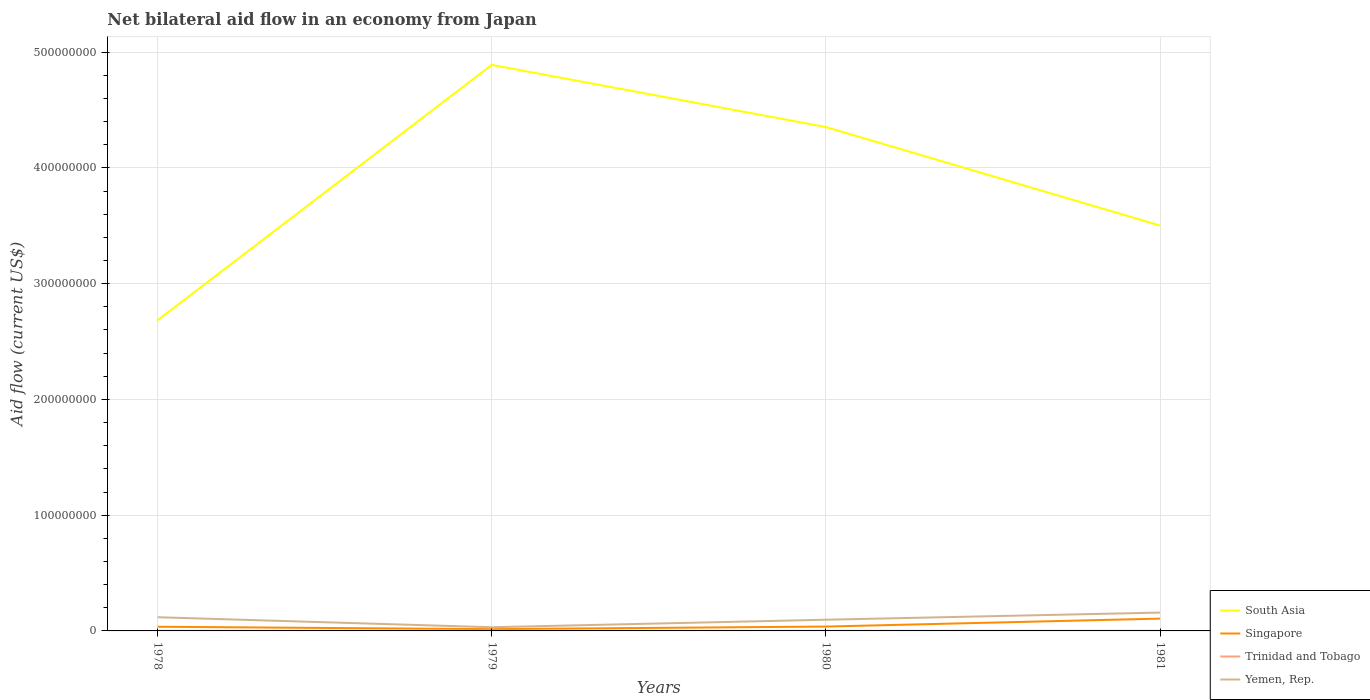Does the line corresponding to Yemen, Rep. intersect with the line corresponding to Singapore?
Offer a very short reply. No. Across all years, what is the maximum net bilateral aid flow in Trinidad and Tobago?
Provide a succinct answer. 9.00e+04. In which year was the net bilateral aid flow in Trinidad and Tobago maximum?
Make the answer very short. 1980. What is the difference between the highest and the second highest net bilateral aid flow in South Asia?
Provide a succinct answer. 2.21e+08. What is the difference between the highest and the lowest net bilateral aid flow in Singapore?
Your answer should be compact. 1. What is the difference between two consecutive major ticks on the Y-axis?
Provide a succinct answer. 1.00e+08. Does the graph contain any zero values?
Provide a short and direct response. No. Does the graph contain grids?
Your response must be concise. Yes. Where does the legend appear in the graph?
Ensure brevity in your answer.  Bottom right. How many legend labels are there?
Ensure brevity in your answer.  4. What is the title of the graph?
Your answer should be compact. Net bilateral aid flow in an economy from Japan. What is the label or title of the Y-axis?
Give a very brief answer. Aid flow (current US$). What is the Aid flow (current US$) of South Asia in 1978?
Provide a succinct answer. 2.68e+08. What is the Aid flow (current US$) of Singapore in 1978?
Your answer should be very brief. 3.60e+06. What is the Aid flow (current US$) of Trinidad and Tobago in 1978?
Offer a very short reply. 1.10e+05. What is the Aid flow (current US$) in Yemen, Rep. in 1978?
Your answer should be very brief. 1.18e+07. What is the Aid flow (current US$) in South Asia in 1979?
Keep it short and to the point. 4.89e+08. What is the Aid flow (current US$) of Singapore in 1979?
Your answer should be compact. 1.52e+06. What is the Aid flow (current US$) of Trinidad and Tobago in 1979?
Keep it short and to the point. 1.90e+05. What is the Aid flow (current US$) of Yemen, Rep. in 1979?
Ensure brevity in your answer.  3.19e+06. What is the Aid flow (current US$) in South Asia in 1980?
Provide a succinct answer. 4.35e+08. What is the Aid flow (current US$) in Singapore in 1980?
Provide a short and direct response. 3.77e+06. What is the Aid flow (current US$) in Trinidad and Tobago in 1980?
Offer a terse response. 9.00e+04. What is the Aid flow (current US$) in Yemen, Rep. in 1980?
Provide a succinct answer. 9.68e+06. What is the Aid flow (current US$) in South Asia in 1981?
Keep it short and to the point. 3.50e+08. What is the Aid flow (current US$) of Singapore in 1981?
Offer a terse response. 1.06e+07. What is the Aid flow (current US$) in Yemen, Rep. in 1981?
Provide a succinct answer. 1.58e+07. Across all years, what is the maximum Aid flow (current US$) in South Asia?
Keep it short and to the point. 4.89e+08. Across all years, what is the maximum Aid flow (current US$) in Singapore?
Offer a terse response. 1.06e+07. Across all years, what is the maximum Aid flow (current US$) of Trinidad and Tobago?
Your answer should be compact. 1.90e+05. Across all years, what is the maximum Aid flow (current US$) in Yemen, Rep.?
Ensure brevity in your answer.  1.58e+07. Across all years, what is the minimum Aid flow (current US$) in South Asia?
Ensure brevity in your answer.  2.68e+08. Across all years, what is the minimum Aid flow (current US$) of Singapore?
Your answer should be very brief. 1.52e+06. Across all years, what is the minimum Aid flow (current US$) in Yemen, Rep.?
Your answer should be compact. 3.19e+06. What is the total Aid flow (current US$) in South Asia in the graph?
Provide a succinct answer. 1.54e+09. What is the total Aid flow (current US$) in Singapore in the graph?
Provide a succinct answer. 1.95e+07. What is the total Aid flow (current US$) in Trinidad and Tobago in the graph?
Give a very brief answer. 5.30e+05. What is the total Aid flow (current US$) in Yemen, Rep. in the graph?
Your answer should be compact. 4.05e+07. What is the difference between the Aid flow (current US$) of South Asia in 1978 and that in 1979?
Ensure brevity in your answer.  -2.21e+08. What is the difference between the Aid flow (current US$) in Singapore in 1978 and that in 1979?
Keep it short and to the point. 2.08e+06. What is the difference between the Aid flow (current US$) in Trinidad and Tobago in 1978 and that in 1979?
Offer a very short reply. -8.00e+04. What is the difference between the Aid flow (current US$) of Yemen, Rep. in 1978 and that in 1979?
Offer a very short reply. 8.63e+06. What is the difference between the Aid flow (current US$) of South Asia in 1978 and that in 1980?
Your response must be concise. -1.67e+08. What is the difference between the Aid flow (current US$) of Trinidad and Tobago in 1978 and that in 1980?
Your answer should be very brief. 2.00e+04. What is the difference between the Aid flow (current US$) of Yemen, Rep. in 1978 and that in 1980?
Your answer should be very brief. 2.14e+06. What is the difference between the Aid flow (current US$) of South Asia in 1978 and that in 1981?
Ensure brevity in your answer.  -8.18e+07. What is the difference between the Aid flow (current US$) of Singapore in 1978 and that in 1981?
Make the answer very short. -7.04e+06. What is the difference between the Aid flow (current US$) of Yemen, Rep. in 1978 and that in 1981?
Your answer should be very brief. -4.03e+06. What is the difference between the Aid flow (current US$) of South Asia in 1979 and that in 1980?
Offer a very short reply. 5.37e+07. What is the difference between the Aid flow (current US$) in Singapore in 1979 and that in 1980?
Keep it short and to the point. -2.25e+06. What is the difference between the Aid flow (current US$) of Yemen, Rep. in 1979 and that in 1980?
Your response must be concise. -6.49e+06. What is the difference between the Aid flow (current US$) in South Asia in 1979 and that in 1981?
Ensure brevity in your answer.  1.39e+08. What is the difference between the Aid flow (current US$) of Singapore in 1979 and that in 1981?
Keep it short and to the point. -9.12e+06. What is the difference between the Aid flow (current US$) in Trinidad and Tobago in 1979 and that in 1981?
Offer a very short reply. 5.00e+04. What is the difference between the Aid flow (current US$) in Yemen, Rep. in 1979 and that in 1981?
Your answer should be compact. -1.27e+07. What is the difference between the Aid flow (current US$) in South Asia in 1980 and that in 1981?
Offer a terse response. 8.51e+07. What is the difference between the Aid flow (current US$) of Singapore in 1980 and that in 1981?
Your answer should be very brief. -6.87e+06. What is the difference between the Aid flow (current US$) in Trinidad and Tobago in 1980 and that in 1981?
Give a very brief answer. -5.00e+04. What is the difference between the Aid flow (current US$) in Yemen, Rep. in 1980 and that in 1981?
Keep it short and to the point. -6.17e+06. What is the difference between the Aid flow (current US$) of South Asia in 1978 and the Aid flow (current US$) of Singapore in 1979?
Provide a succinct answer. 2.67e+08. What is the difference between the Aid flow (current US$) of South Asia in 1978 and the Aid flow (current US$) of Trinidad and Tobago in 1979?
Offer a very short reply. 2.68e+08. What is the difference between the Aid flow (current US$) of South Asia in 1978 and the Aid flow (current US$) of Yemen, Rep. in 1979?
Provide a succinct answer. 2.65e+08. What is the difference between the Aid flow (current US$) in Singapore in 1978 and the Aid flow (current US$) in Trinidad and Tobago in 1979?
Provide a succinct answer. 3.41e+06. What is the difference between the Aid flow (current US$) in Singapore in 1978 and the Aid flow (current US$) in Yemen, Rep. in 1979?
Provide a succinct answer. 4.10e+05. What is the difference between the Aid flow (current US$) of Trinidad and Tobago in 1978 and the Aid flow (current US$) of Yemen, Rep. in 1979?
Your response must be concise. -3.08e+06. What is the difference between the Aid flow (current US$) of South Asia in 1978 and the Aid flow (current US$) of Singapore in 1980?
Your answer should be very brief. 2.65e+08. What is the difference between the Aid flow (current US$) in South Asia in 1978 and the Aid flow (current US$) in Trinidad and Tobago in 1980?
Ensure brevity in your answer.  2.68e+08. What is the difference between the Aid flow (current US$) of South Asia in 1978 and the Aid flow (current US$) of Yemen, Rep. in 1980?
Your answer should be compact. 2.59e+08. What is the difference between the Aid flow (current US$) of Singapore in 1978 and the Aid flow (current US$) of Trinidad and Tobago in 1980?
Your response must be concise. 3.51e+06. What is the difference between the Aid flow (current US$) in Singapore in 1978 and the Aid flow (current US$) in Yemen, Rep. in 1980?
Make the answer very short. -6.08e+06. What is the difference between the Aid flow (current US$) in Trinidad and Tobago in 1978 and the Aid flow (current US$) in Yemen, Rep. in 1980?
Give a very brief answer. -9.57e+06. What is the difference between the Aid flow (current US$) of South Asia in 1978 and the Aid flow (current US$) of Singapore in 1981?
Your answer should be very brief. 2.58e+08. What is the difference between the Aid flow (current US$) in South Asia in 1978 and the Aid flow (current US$) in Trinidad and Tobago in 1981?
Give a very brief answer. 2.68e+08. What is the difference between the Aid flow (current US$) of South Asia in 1978 and the Aid flow (current US$) of Yemen, Rep. in 1981?
Provide a short and direct response. 2.53e+08. What is the difference between the Aid flow (current US$) in Singapore in 1978 and the Aid flow (current US$) in Trinidad and Tobago in 1981?
Offer a terse response. 3.46e+06. What is the difference between the Aid flow (current US$) of Singapore in 1978 and the Aid flow (current US$) of Yemen, Rep. in 1981?
Offer a very short reply. -1.22e+07. What is the difference between the Aid flow (current US$) of Trinidad and Tobago in 1978 and the Aid flow (current US$) of Yemen, Rep. in 1981?
Your response must be concise. -1.57e+07. What is the difference between the Aid flow (current US$) of South Asia in 1979 and the Aid flow (current US$) of Singapore in 1980?
Give a very brief answer. 4.85e+08. What is the difference between the Aid flow (current US$) in South Asia in 1979 and the Aid flow (current US$) in Trinidad and Tobago in 1980?
Make the answer very short. 4.89e+08. What is the difference between the Aid flow (current US$) of South Asia in 1979 and the Aid flow (current US$) of Yemen, Rep. in 1980?
Give a very brief answer. 4.79e+08. What is the difference between the Aid flow (current US$) in Singapore in 1979 and the Aid flow (current US$) in Trinidad and Tobago in 1980?
Your answer should be compact. 1.43e+06. What is the difference between the Aid flow (current US$) in Singapore in 1979 and the Aid flow (current US$) in Yemen, Rep. in 1980?
Keep it short and to the point. -8.16e+06. What is the difference between the Aid flow (current US$) in Trinidad and Tobago in 1979 and the Aid flow (current US$) in Yemen, Rep. in 1980?
Your response must be concise. -9.49e+06. What is the difference between the Aid flow (current US$) of South Asia in 1979 and the Aid flow (current US$) of Singapore in 1981?
Give a very brief answer. 4.78e+08. What is the difference between the Aid flow (current US$) of South Asia in 1979 and the Aid flow (current US$) of Trinidad and Tobago in 1981?
Offer a very short reply. 4.89e+08. What is the difference between the Aid flow (current US$) of South Asia in 1979 and the Aid flow (current US$) of Yemen, Rep. in 1981?
Your answer should be very brief. 4.73e+08. What is the difference between the Aid flow (current US$) in Singapore in 1979 and the Aid flow (current US$) in Trinidad and Tobago in 1981?
Offer a very short reply. 1.38e+06. What is the difference between the Aid flow (current US$) in Singapore in 1979 and the Aid flow (current US$) in Yemen, Rep. in 1981?
Provide a short and direct response. -1.43e+07. What is the difference between the Aid flow (current US$) in Trinidad and Tobago in 1979 and the Aid flow (current US$) in Yemen, Rep. in 1981?
Make the answer very short. -1.57e+07. What is the difference between the Aid flow (current US$) of South Asia in 1980 and the Aid flow (current US$) of Singapore in 1981?
Offer a very short reply. 4.25e+08. What is the difference between the Aid flow (current US$) of South Asia in 1980 and the Aid flow (current US$) of Trinidad and Tobago in 1981?
Offer a very short reply. 4.35e+08. What is the difference between the Aid flow (current US$) in South Asia in 1980 and the Aid flow (current US$) in Yemen, Rep. in 1981?
Your response must be concise. 4.19e+08. What is the difference between the Aid flow (current US$) of Singapore in 1980 and the Aid flow (current US$) of Trinidad and Tobago in 1981?
Give a very brief answer. 3.63e+06. What is the difference between the Aid flow (current US$) in Singapore in 1980 and the Aid flow (current US$) in Yemen, Rep. in 1981?
Offer a very short reply. -1.21e+07. What is the difference between the Aid flow (current US$) in Trinidad and Tobago in 1980 and the Aid flow (current US$) in Yemen, Rep. in 1981?
Your answer should be very brief. -1.58e+07. What is the average Aid flow (current US$) of South Asia per year?
Your response must be concise. 3.86e+08. What is the average Aid flow (current US$) of Singapore per year?
Make the answer very short. 4.88e+06. What is the average Aid flow (current US$) in Trinidad and Tobago per year?
Your answer should be very brief. 1.32e+05. What is the average Aid flow (current US$) of Yemen, Rep. per year?
Provide a short and direct response. 1.01e+07. In the year 1978, what is the difference between the Aid flow (current US$) in South Asia and Aid flow (current US$) in Singapore?
Give a very brief answer. 2.65e+08. In the year 1978, what is the difference between the Aid flow (current US$) in South Asia and Aid flow (current US$) in Trinidad and Tobago?
Ensure brevity in your answer.  2.68e+08. In the year 1978, what is the difference between the Aid flow (current US$) of South Asia and Aid flow (current US$) of Yemen, Rep.?
Your answer should be very brief. 2.57e+08. In the year 1978, what is the difference between the Aid flow (current US$) in Singapore and Aid flow (current US$) in Trinidad and Tobago?
Make the answer very short. 3.49e+06. In the year 1978, what is the difference between the Aid flow (current US$) of Singapore and Aid flow (current US$) of Yemen, Rep.?
Your response must be concise. -8.22e+06. In the year 1978, what is the difference between the Aid flow (current US$) of Trinidad and Tobago and Aid flow (current US$) of Yemen, Rep.?
Your answer should be very brief. -1.17e+07. In the year 1979, what is the difference between the Aid flow (current US$) in South Asia and Aid flow (current US$) in Singapore?
Make the answer very short. 4.88e+08. In the year 1979, what is the difference between the Aid flow (current US$) of South Asia and Aid flow (current US$) of Trinidad and Tobago?
Make the answer very short. 4.89e+08. In the year 1979, what is the difference between the Aid flow (current US$) in South Asia and Aid flow (current US$) in Yemen, Rep.?
Keep it short and to the point. 4.86e+08. In the year 1979, what is the difference between the Aid flow (current US$) of Singapore and Aid flow (current US$) of Trinidad and Tobago?
Your answer should be compact. 1.33e+06. In the year 1979, what is the difference between the Aid flow (current US$) in Singapore and Aid flow (current US$) in Yemen, Rep.?
Offer a terse response. -1.67e+06. In the year 1979, what is the difference between the Aid flow (current US$) in Trinidad and Tobago and Aid flow (current US$) in Yemen, Rep.?
Your answer should be compact. -3.00e+06. In the year 1980, what is the difference between the Aid flow (current US$) of South Asia and Aid flow (current US$) of Singapore?
Provide a short and direct response. 4.32e+08. In the year 1980, what is the difference between the Aid flow (current US$) of South Asia and Aid flow (current US$) of Trinidad and Tobago?
Your answer should be compact. 4.35e+08. In the year 1980, what is the difference between the Aid flow (current US$) in South Asia and Aid flow (current US$) in Yemen, Rep.?
Provide a succinct answer. 4.26e+08. In the year 1980, what is the difference between the Aid flow (current US$) in Singapore and Aid flow (current US$) in Trinidad and Tobago?
Make the answer very short. 3.68e+06. In the year 1980, what is the difference between the Aid flow (current US$) in Singapore and Aid flow (current US$) in Yemen, Rep.?
Your answer should be very brief. -5.91e+06. In the year 1980, what is the difference between the Aid flow (current US$) in Trinidad and Tobago and Aid flow (current US$) in Yemen, Rep.?
Keep it short and to the point. -9.59e+06. In the year 1981, what is the difference between the Aid flow (current US$) in South Asia and Aid flow (current US$) in Singapore?
Ensure brevity in your answer.  3.40e+08. In the year 1981, what is the difference between the Aid flow (current US$) of South Asia and Aid flow (current US$) of Trinidad and Tobago?
Offer a terse response. 3.50e+08. In the year 1981, what is the difference between the Aid flow (current US$) in South Asia and Aid flow (current US$) in Yemen, Rep.?
Offer a very short reply. 3.34e+08. In the year 1981, what is the difference between the Aid flow (current US$) in Singapore and Aid flow (current US$) in Trinidad and Tobago?
Offer a very short reply. 1.05e+07. In the year 1981, what is the difference between the Aid flow (current US$) in Singapore and Aid flow (current US$) in Yemen, Rep.?
Your response must be concise. -5.21e+06. In the year 1981, what is the difference between the Aid flow (current US$) in Trinidad and Tobago and Aid flow (current US$) in Yemen, Rep.?
Offer a very short reply. -1.57e+07. What is the ratio of the Aid flow (current US$) of South Asia in 1978 to that in 1979?
Ensure brevity in your answer.  0.55. What is the ratio of the Aid flow (current US$) in Singapore in 1978 to that in 1979?
Offer a terse response. 2.37. What is the ratio of the Aid flow (current US$) in Trinidad and Tobago in 1978 to that in 1979?
Ensure brevity in your answer.  0.58. What is the ratio of the Aid flow (current US$) of Yemen, Rep. in 1978 to that in 1979?
Your answer should be compact. 3.71. What is the ratio of the Aid flow (current US$) of South Asia in 1978 to that in 1980?
Offer a very short reply. 0.62. What is the ratio of the Aid flow (current US$) of Singapore in 1978 to that in 1980?
Offer a terse response. 0.95. What is the ratio of the Aid flow (current US$) in Trinidad and Tobago in 1978 to that in 1980?
Make the answer very short. 1.22. What is the ratio of the Aid flow (current US$) in Yemen, Rep. in 1978 to that in 1980?
Keep it short and to the point. 1.22. What is the ratio of the Aid flow (current US$) of South Asia in 1978 to that in 1981?
Offer a very short reply. 0.77. What is the ratio of the Aid flow (current US$) in Singapore in 1978 to that in 1981?
Provide a succinct answer. 0.34. What is the ratio of the Aid flow (current US$) in Trinidad and Tobago in 1978 to that in 1981?
Provide a succinct answer. 0.79. What is the ratio of the Aid flow (current US$) in Yemen, Rep. in 1978 to that in 1981?
Provide a succinct answer. 0.75. What is the ratio of the Aid flow (current US$) of South Asia in 1979 to that in 1980?
Provide a succinct answer. 1.12. What is the ratio of the Aid flow (current US$) in Singapore in 1979 to that in 1980?
Your response must be concise. 0.4. What is the ratio of the Aid flow (current US$) of Trinidad and Tobago in 1979 to that in 1980?
Offer a very short reply. 2.11. What is the ratio of the Aid flow (current US$) in Yemen, Rep. in 1979 to that in 1980?
Offer a very short reply. 0.33. What is the ratio of the Aid flow (current US$) in South Asia in 1979 to that in 1981?
Your answer should be compact. 1.4. What is the ratio of the Aid flow (current US$) in Singapore in 1979 to that in 1981?
Your answer should be compact. 0.14. What is the ratio of the Aid flow (current US$) in Trinidad and Tobago in 1979 to that in 1981?
Your answer should be compact. 1.36. What is the ratio of the Aid flow (current US$) of Yemen, Rep. in 1979 to that in 1981?
Provide a succinct answer. 0.2. What is the ratio of the Aid flow (current US$) of South Asia in 1980 to that in 1981?
Your response must be concise. 1.24. What is the ratio of the Aid flow (current US$) in Singapore in 1980 to that in 1981?
Provide a short and direct response. 0.35. What is the ratio of the Aid flow (current US$) of Trinidad and Tobago in 1980 to that in 1981?
Your response must be concise. 0.64. What is the ratio of the Aid flow (current US$) of Yemen, Rep. in 1980 to that in 1981?
Provide a succinct answer. 0.61. What is the difference between the highest and the second highest Aid flow (current US$) of South Asia?
Keep it short and to the point. 5.37e+07. What is the difference between the highest and the second highest Aid flow (current US$) in Singapore?
Offer a very short reply. 6.87e+06. What is the difference between the highest and the second highest Aid flow (current US$) in Trinidad and Tobago?
Provide a succinct answer. 5.00e+04. What is the difference between the highest and the second highest Aid flow (current US$) in Yemen, Rep.?
Offer a very short reply. 4.03e+06. What is the difference between the highest and the lowest Aid flow (current US$) of South Asia?
Give a very brief answer. 2.21e+08. What is the difference between the highest and the lowest Aid flow (current US$) in Singapore?
Provide a short and direct response. 9.12e+06. What is the difference between the highest and the lowest Aid flow (current US$) of Yemen, Rep.?
Offer a very short reply. 1.27e+07. 